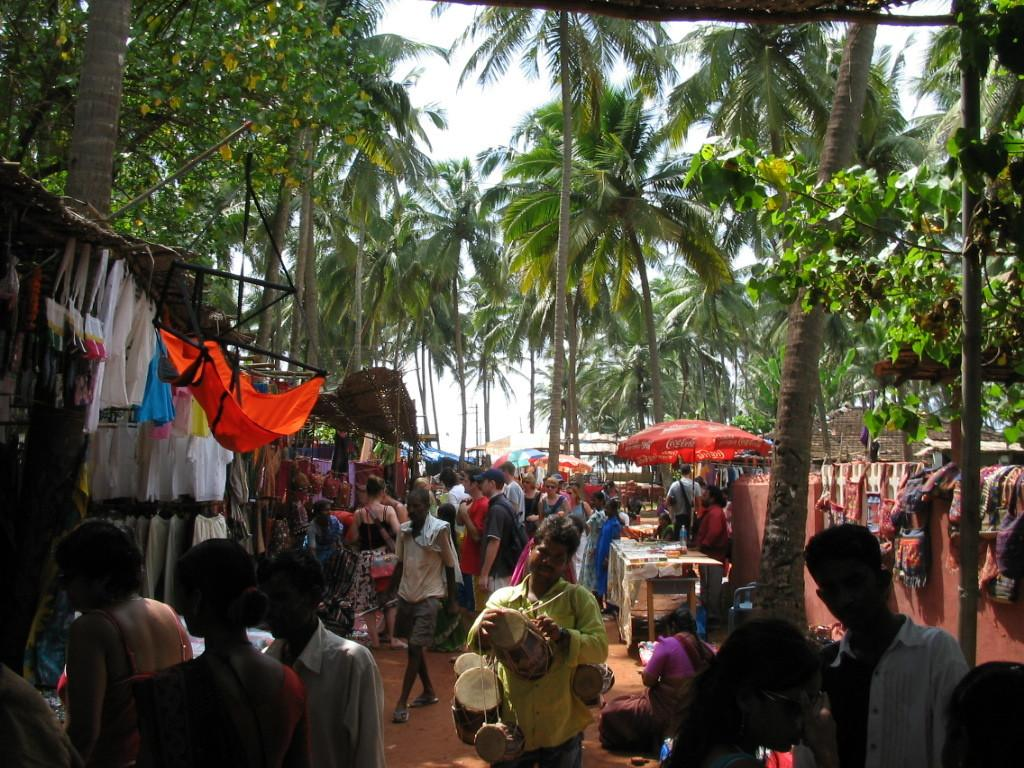How many people are in the image? There is a group of people in the image. What are the people in the image doing? The people are standing. What can be seen in the background of the image? There are trees, the sky, a tent, and a banner visible in the background of the image. What advice is the dad giving to the group of people in the image? There is no dad present in the image, and therefore no advice-giving can be observed. 